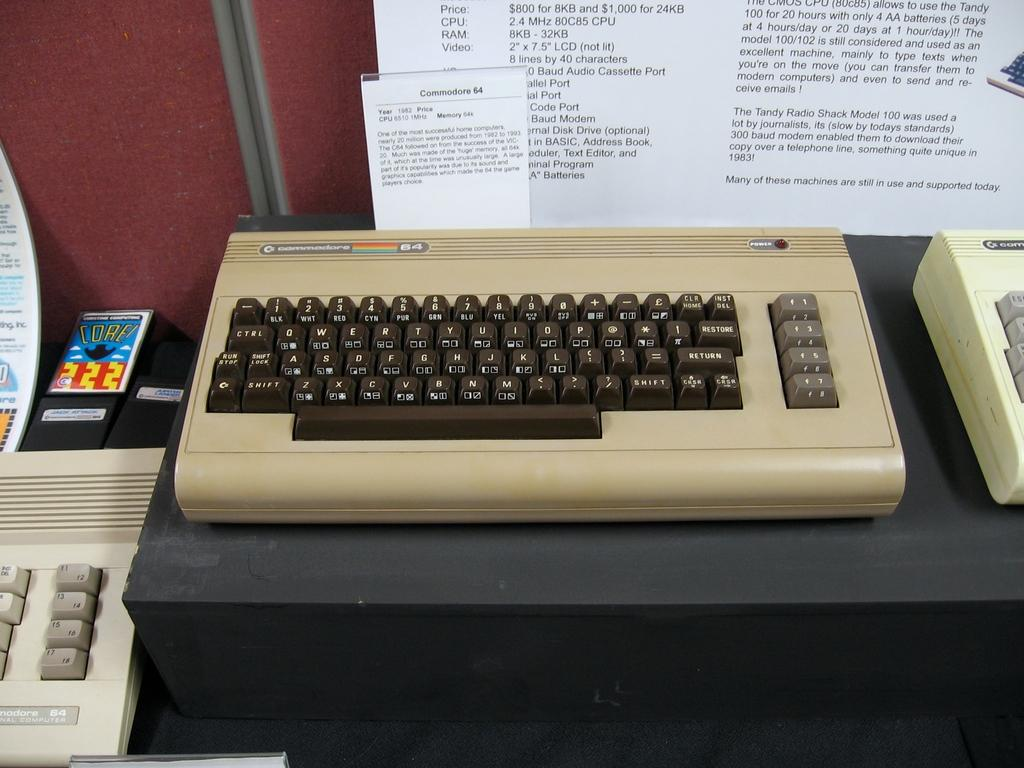<image>
Present a compact description of the photo's key features. An old computer keyboard next to a bunch of other old computer keyboards 